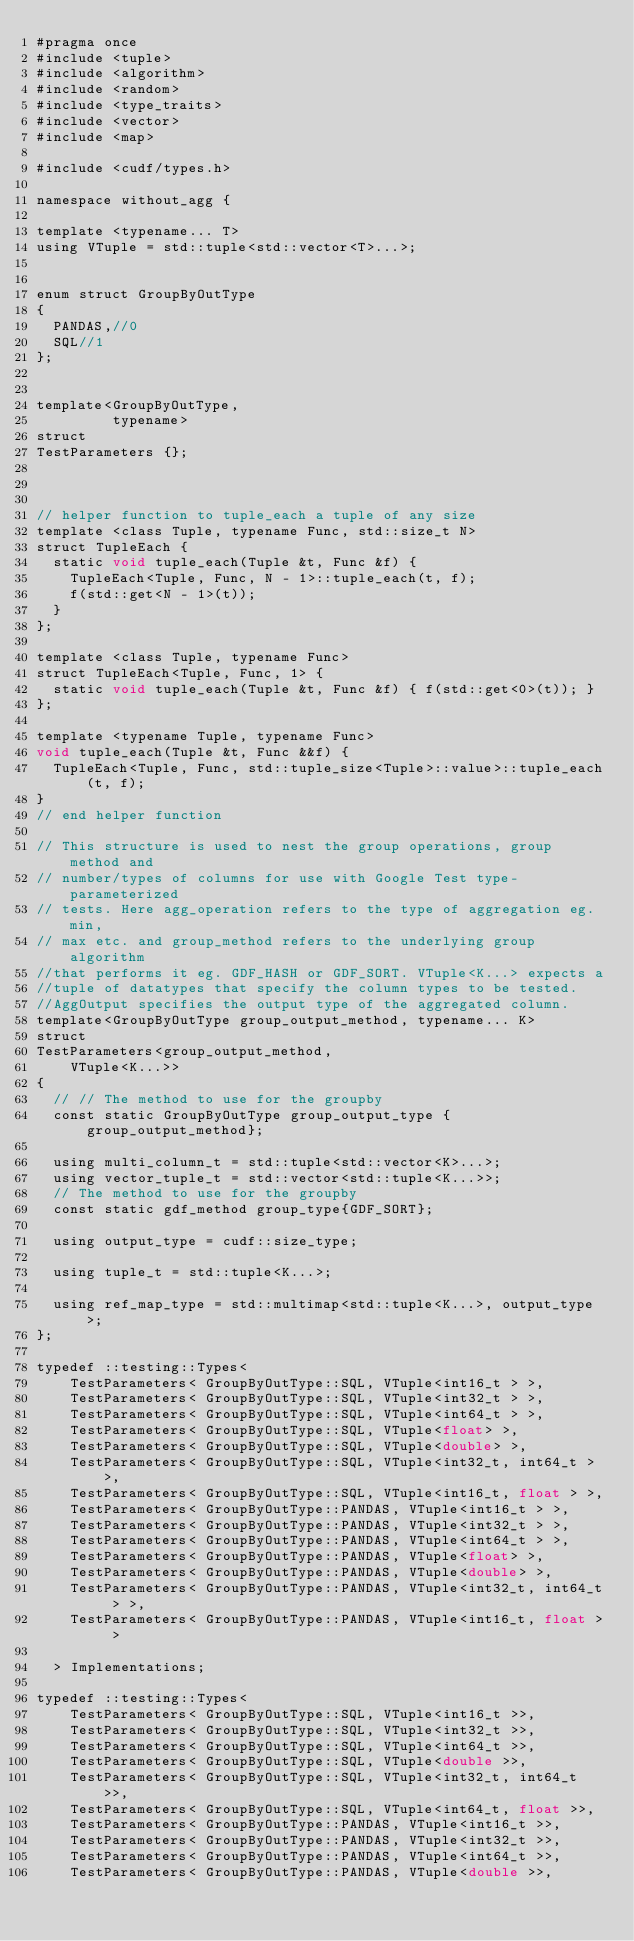Convert code to text. <code><loc_0><loc_0><loc_500><loc_500><_Cuda_>#pragma once
#include <tuple>
#include <algorithm>
#include <random>
#include <type_traits>
#include <vector>
#include <map>

#include <cudf/types.h>

namespace without_agg {

template <typename... T>
using VTuple = std::tuple<std::vector<T>...>;


enum struct GroupByOutType
{
  PANDAS,//0
  SQL//1
};


template<GroupByOutType,
         typename>
struct
TestParameters {};



// helper function to tuple_each a tuple of any size
template <class Tuple, typename Func, std::size_t N>
struct TupleEach {
  static void tuple_each(Tuple &t, Func &f) {
    TupleEach<Tuple, Func, N - 1>::tuple_each(t, f);
    f(std::get<N - 1>(t));
  }
};

template <class Tuple, typename Func>
struct TupleEach<Tuple, Func, 1> {
  static void tuple_each(Tuple &t, Func &f) { f(std::get<0>(t)); }
};

template <typename Tuple, typename Func>
void tuple_each(Tuple &t, Func &&f) {
  TupleEach<Tuple, Func, std::tuple_size<Tuple>::value>::tuple_each(t, f);
}
// end helper function

// This structure is used to nest the group operations, group method and
// number/types of columns for use with Google Test type-parameterized
// tests. Here agg_operation refers to the type of aggregation eg. min,
// max etc. and group_method refers to the underlying group algorithm
//that performs it eg. GDF_HASH or GDF_SORT. VTuple<K...> expects a
//tuple of datatypes that specify the column types to be tested.
//AggOutput specifies the output type of the aggregated column.
template<GroupByOutType group_output_method, typename... K>
struct
TestParameters<group_output_method,
    VTuple<K...>>
{
  // // The method to use for the groupby
  const static GroupByOutType group_output_type {group_output_method};

  using multi_column_t = std::tuple<std::vector<K>...>;
  using vector_tuple_t = std::vector<std::tuple<K...>>;
  // The method to use for the groupby
  const static gdf_method group_type{GDF_SORT};

  using output_type = cudf::size_type;

  using tuple_t = std::tuple<K...>;

  using ref_map_type = std::multimap<std::tuple<K...>, output_type>;
};

typedef ::testing::Types<
    TestParameters< GroupByOutType::SQL, VTuple<int16_t > >,
    TestParameters< GroupByOutType::SQL, VTuple<int32_t > >,
    TestParameters< GroupByOutType::SQL, VTuple<int64_t > >,
    TestParameters< GroupByOutType::SQL, VTuple<float> >,
    TestParameters< GroupByOutType::SQL, VTuple<double> >,
    TestParameters< GroupByOutType::SQL, VTuple<int32_t, int64_t > >,
    TestParameters< GroupByOutType::SQL, VTuple<int16_t, float > >,
    TestParameters< GroupByOutType::PANDAS, VTuple<int16_t > >,
    TestParameters< GroupByOutType::PANDAS, VTuple<int32_t > >,
    TestParameters< GroupByOutType::PANDAS, VTuple<int64_t > >,
    TestParameters< GroupByOutType::PANDAS, VTuple<float> >,
    TestParameters< GroupByOutType::PANDAS, VTuple<double> >,
    TestParameters< GroupByOutType::PANDAS, VTuple<int32_t, int64_t > >,
    TestParameters< GroupByOutType::PANDAS, VTuple<int16_t, float > >
    
  > Implementations;

typedef ::testing::Types<
    TestParameters< GroupByOutType::SQL, VTuple<int16_t >>,
    TestParameters< GroupByOutType::SQL, VTuple<int32_t >>,
    TestParameters< GroupByOutType::SQL, VTuple<int64_t >>,
    TestParameters< GroupByOutType::SQL, VTuple<double >>,    
    TestParameters< GroupByOutType::SQL, VTuple<int32_t, int64_t >>,
    TestParameters< GroupByOutType::SQL, VTuple<int64_t, float >>,
    TestParameters< GroupByOutType::PANDAS, VTuple<int16_t >>,
    TestParameters< GroupByOutType::PANDAS, VTuple<int32_t >>,
    TestParameters< GroupByOutType::PANDAS, VTuple<int64_t >>,
    TestParameters< GroupByOutType::PANDAS, VTuple<double >>,    </code> 